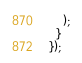<code> <loc_0><loc_0><loc_500><loc_500><_JavaScript_>    );
  }
});
</code> 